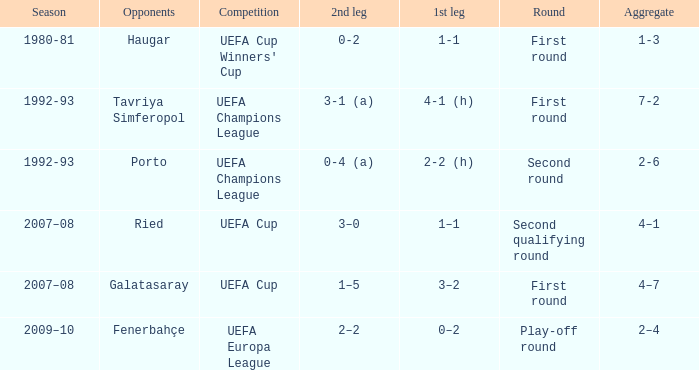 what's the 1st leg where opponents is galatasaray 3–2. 